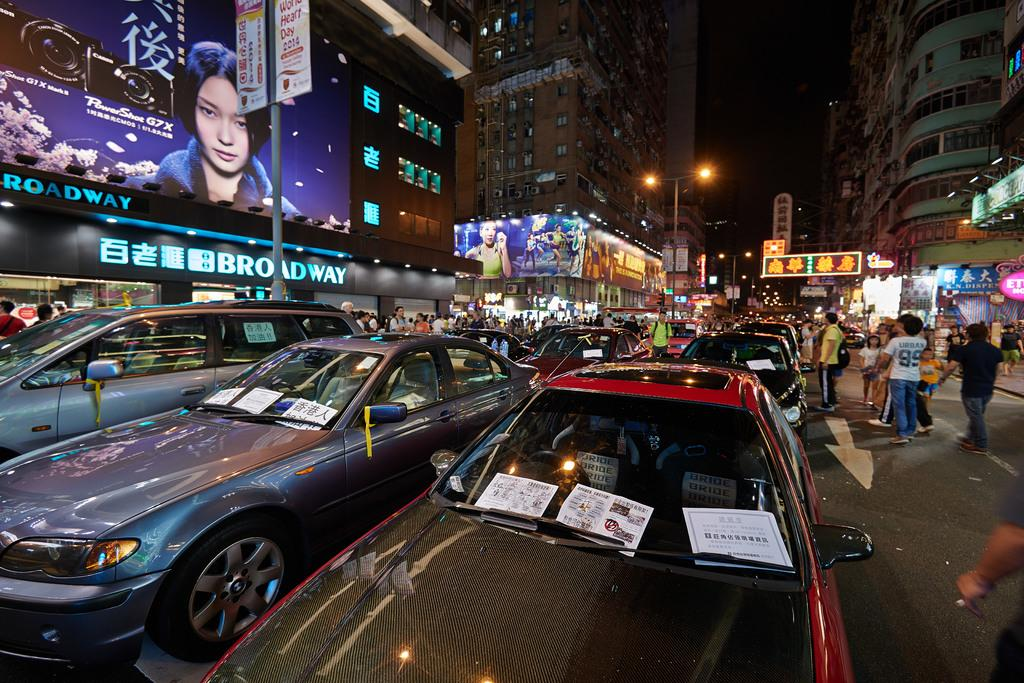Provide a one-sentence caption for the provided image. A busy, warm, evening  with several people looking at the Broadway billboard. 